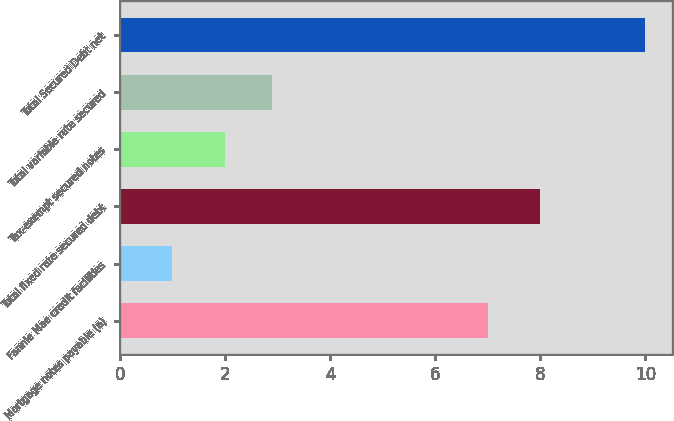Convert chart to OTSL. <chart><loc_0><loc_0><loc_500><loc_500><bar_chart><fcel>Mortgage notes payable (a)<fcel>Fannie Mae credit facilities<fcel>Total fixed rate secured debt<fcel>Tax-exempt secured notes<fcel>Total variable rate secured<fcel>Total Secured Debt net<nl><fcel>7<fcel>1<fcel>8<fcel>2<fcel>2.9<fcel>10<nl></chart> 